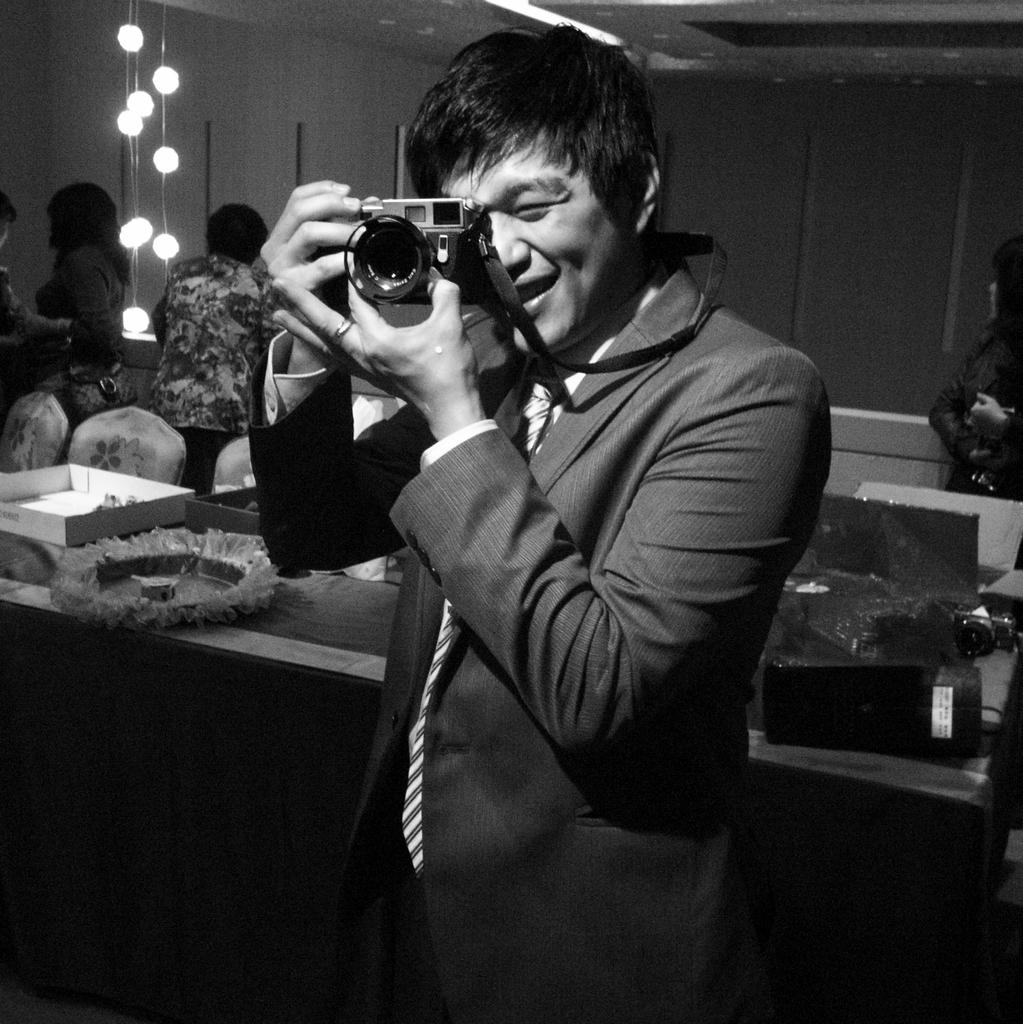Who is the main subject in the image? There is a man in the middle of the image. What is the man wearing? The man is wearing a suit and tie. What is the man holding in the image? The man is holding a camera. What can be seen in the background of the image? There is a box, a chair, people, lights, a table, and another camera in the background of the image. What type of stamp can be seen on the man's forehead in the image? There is no stamp visible on the man's forehead in the image. 